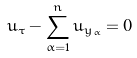Convert formula to latex. <formula><loc_0><loc_0><loc_500><loc_500>u _ { \tau } - \sum _ { \alpha = 1 } ^ { n } u _ { y _ { \alpha } } = 0</formula> 